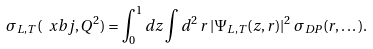Convert formula to latex. <formula><loc_0><loc_0><loc_500><loc_500>\sigma _ { L , T } ( \ x b j , Q ^ { 2 } ) = \int _ { 0 } ^ { 1 } d z \int d ^ { 2 } \, r \, | \Psi _ { L , T } ( z , r ) | ^ { 2 } \, \sigma _ { D P } ( r , \dots ) .</formula> 